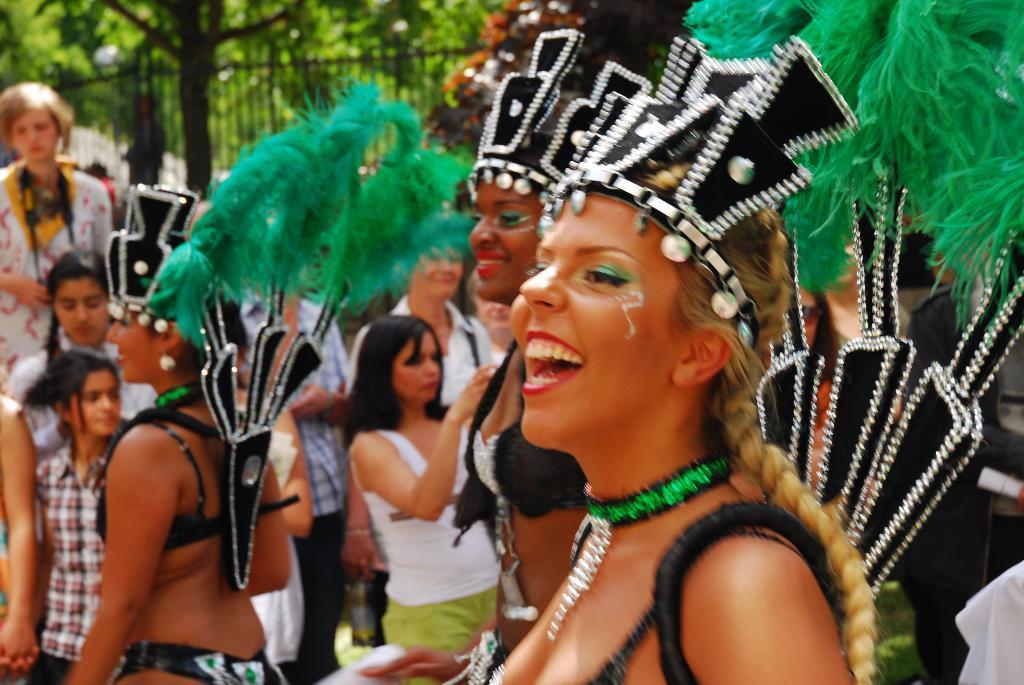Can you describe this image briefly? In the image in the center we can see three persons were standing and they were in different costumes. And they were smiling,which we can see on their faces. In the background we can see trees,few people were standing,fence etc.  